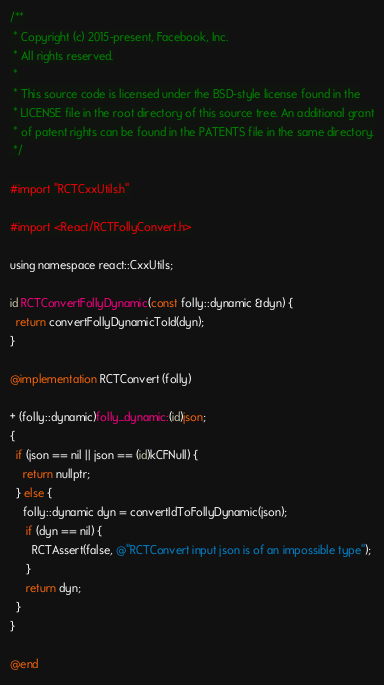Convert code to text. <code><loc_0><loc_0><loc_500><loc_500><_ObjectiveC_>/**
 * Copyright (c) 2015-present, Facebook, Inc.
 * All rights reserved.
 *
 * This source code is licensed under the BSD-style license found in the
 * LICENSE file in the root directory of this source tree. An additional grant
 * of patent rights can be found in the PATENTS file in the same directory.
 */

#import "RCTCxxUtils.h"

#import <React/RCTFollyConvert.h>

using namespace react::CxxUtils;

id RCTConvertFollyDynamic(const folly::dynamic &dyn) {
  return convertFollyDynamicToId(dyn);
}

@implementation RCTConvert (folly)

+ (folly::dynamic)folly_dynamic:(id)json;
{
  if (json == nil || json == (id)kCFNull) {
    return nullptr;
  } else {
    folly::dynamic dyn = convertIdToFollyDynamic(json);
     if (dyn == nil) {
       RCTAssert(false, @"RCTConvert input json is of an impossible type");
     }
     return dyn;
  }
}

@end
</code> 